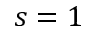Convert formula to latex. <formula><loc_0><loc_0><loc_500><loc_500>s = 1</formula> 